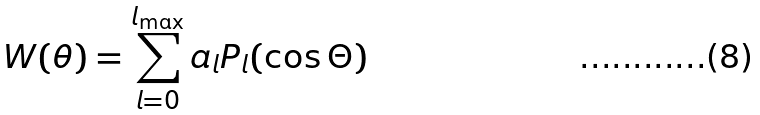Convert formula to latex. <formula><loc_0><loc_0><loc_500><loc_500>W ( \theta ) = \sum _ { l = 0 } ^ { l _ { \max } } a _ { l } P _ { l } ( \cos \Theta )</formula> 